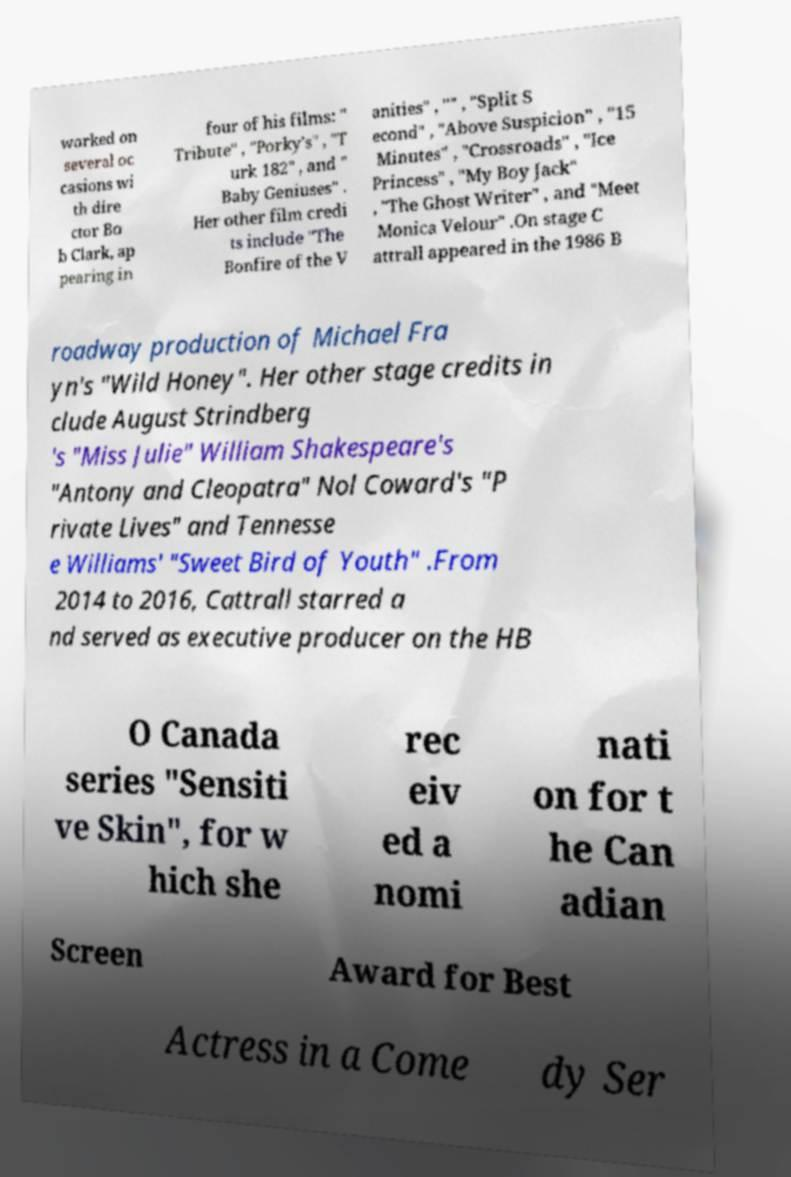Can you read and provide the text displayed in the image?This photo seems to have some interesting text. Can you extract and type it out for me? worked on several oc casions wi th dire ctor Bo b Clark, ap pearing in four of his films: " Tribute" , "Porky's" , "T urk 182" , and " Baby Geniuses" . Her other film credi ts include "The Bonfire of the V anities" , "" , "Split S econd" , "Above Suspicion" , "15 Minutes" , "Crossroads" , "Ice Princess" , "My Boy Jack" , "The Ghost Writer" , and "Meet Monica Velour" .On stage C attrall appeared in the 1986 B roadway production of Michael Fra yn's "Wild Honey". Her other stage credits in clude August Strindberg 's "Miss Julie" William Shakespeare's "Antony and Cleopatra" Nol Coward's "P rivate Lives" and Tennesse e Williams' "Sweet Bird of Youth" .From 2014 to 2016, Cattrall starred a nd served as executive producer on the HB O Canada series "Sensiti ve Skin", for w hich she rec eiv ed a nomi nati on for t he Can adian Screen Award for Best Actress in a Come dy Ser 